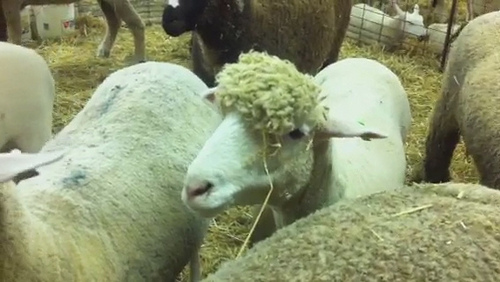The sheep is standing where? The sheep is standing in a pen. 